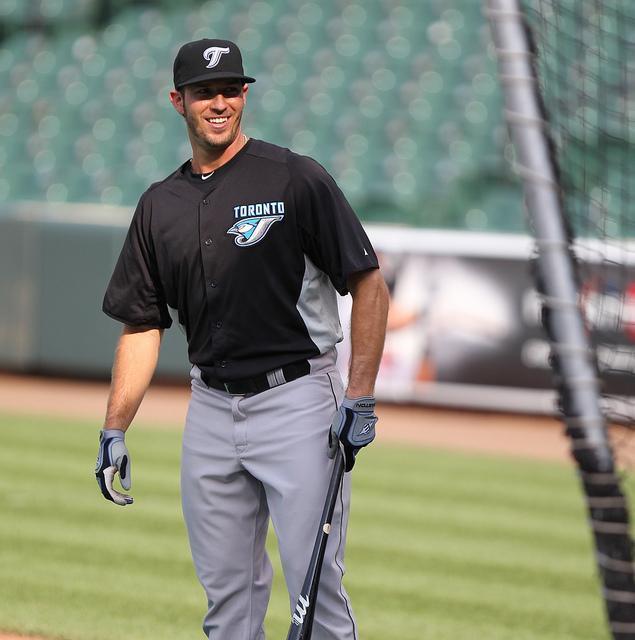How many horses have a rider on them?
Give a very brief answer. 0. 